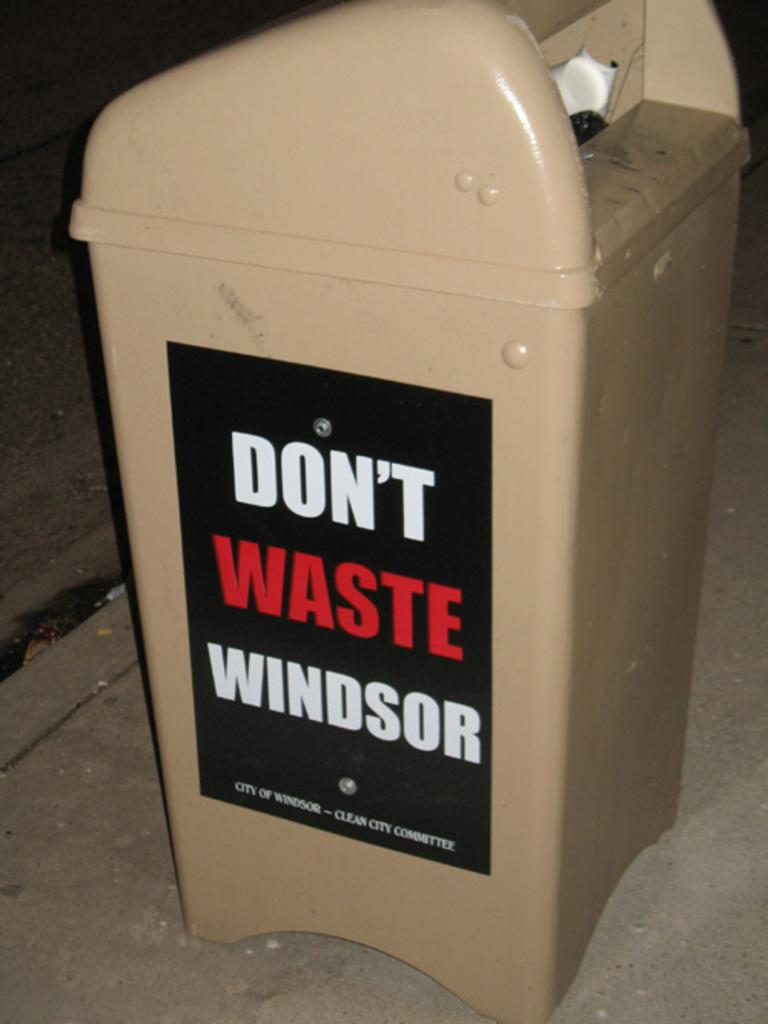<image>
Offer a succinct explanation of the picture presented. A trash bin with a label on it that says Don't waste Windsor 